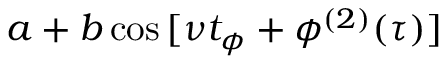Convert formula to latex. <formula><loc_0><loc_0><loc_500><loc_500>a + b \cos { [ \nu t _ { \phi } + \phi ^ { ( 2 ) } ( \tau ) ] }</formula> 